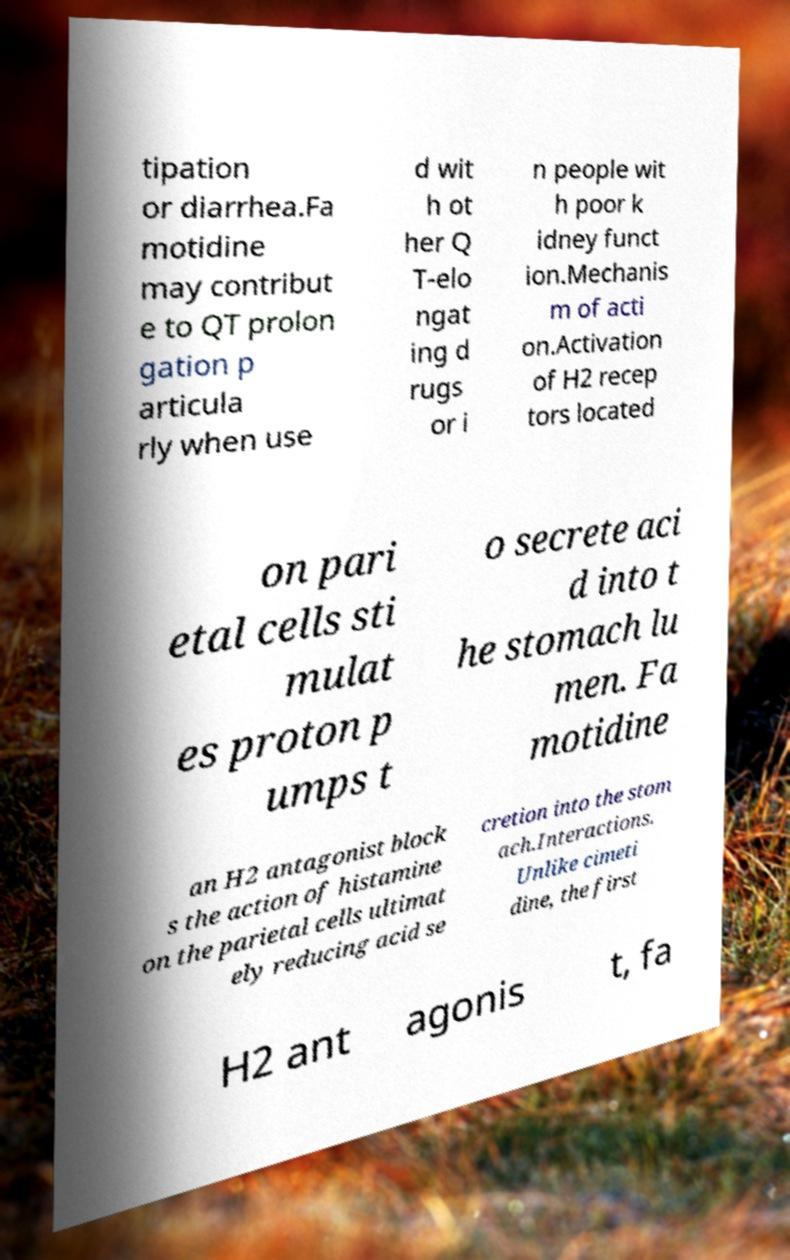Please identify and transcribe the text found in this image. tipation or diarrhea.Fa motidine may contribut e to QT prolon gation p articula rly when use d wit h ot her Q T-elo ngat ing d rugs or i n people wit h poor k idney funct ion.Mechanis m of acti on.Activation of H2 recep tors located on pari etal cells sti mulat es proton p umps t o secrete aci d into t he stomach lu men. Fa motidine an H2 antagonist block s the action of histamine on the parietal cells ultimat ely reducing acid se cretion into the stom ach.Interactions. Unlike cimeti dine, the first H2 ant agonis t, fa 